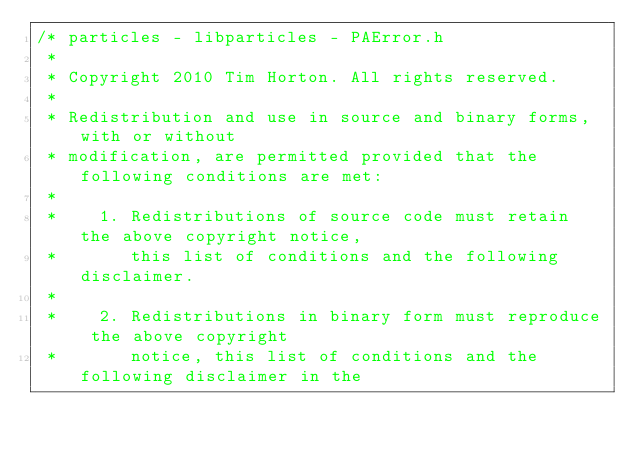<code> <loc_0><loc_0><loc_500><loc_500><_C_>/* particles - libparticles - PAError.h
 *
 * Copyright 2010 Tim Horton. All rights reserved.
 *
 * Redistribution and use in source and binary forms, with or without
 * modification, are permitted provided that the following conditions are met:
 *
 *    1. Redistributions of source code must retain the above copyright notice,
 *       this list of conditions and the following disclaimer.
 *
 *    2. Redistributions in binary form must reproduce the above copyright
 *       notice, this list of conditions and the following disclaimer in the</code> 